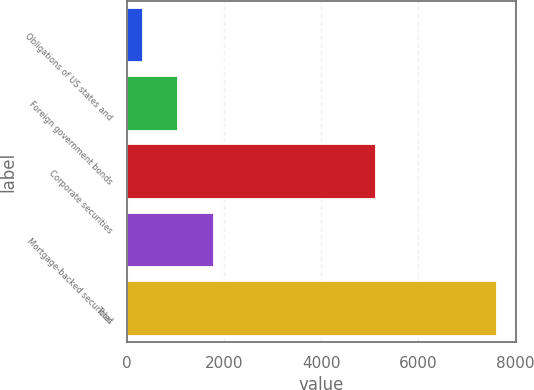<chart> <loc_0><loc_0><loc_500><loc_500><bar_chart><fcel>Obligations of US states and<fcel>Foreign government bonds<fcel>Corporate securities<fcel>Mortgage-backed securities<fcel>Total<nl><fcel>331<fcel>1059.9<fcel>5131<fcel>1788.8<fcel>7620<nl></chart> 